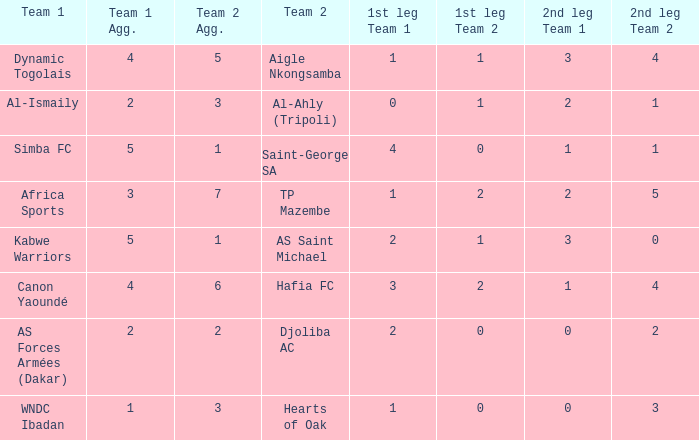When Kabwe Warriors (team 1) played, what was the result of the 1st leg? 2-1. 